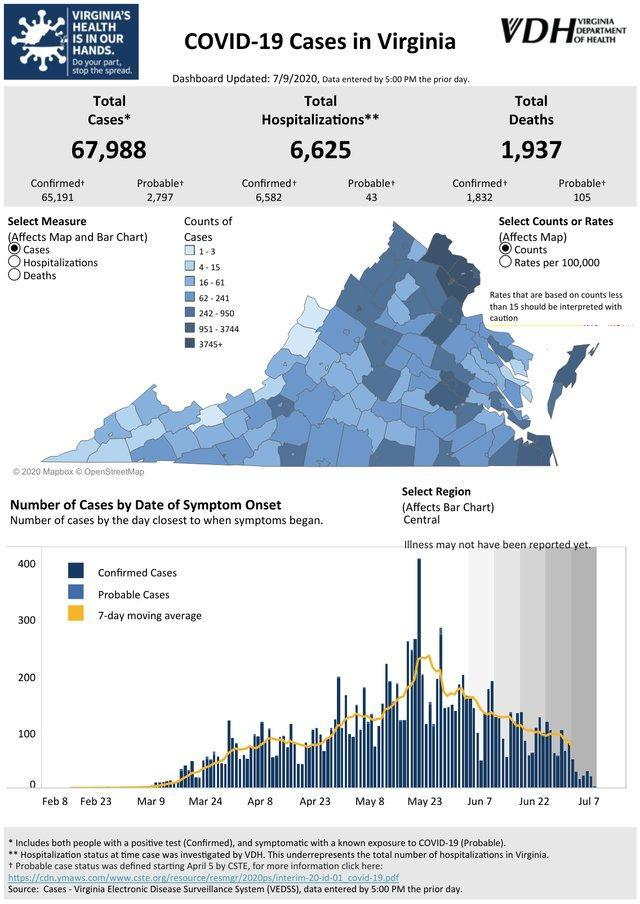How many total Covid-19 deaths were reported in Virginia as of 7/9/2020?
Answer the question with a short phrase. 1,937 What is the total number of COVID-19 cases reported in Virginia as of 7/9/2020? 67,988 What is the total number of confirmed COVID-19 cases reported in Virginia as of 7/9/2020? 65,191 What is the number of confirmed hospitalization of Covid positive cases reported in Virginia as of 7/9/2020? 6,582 